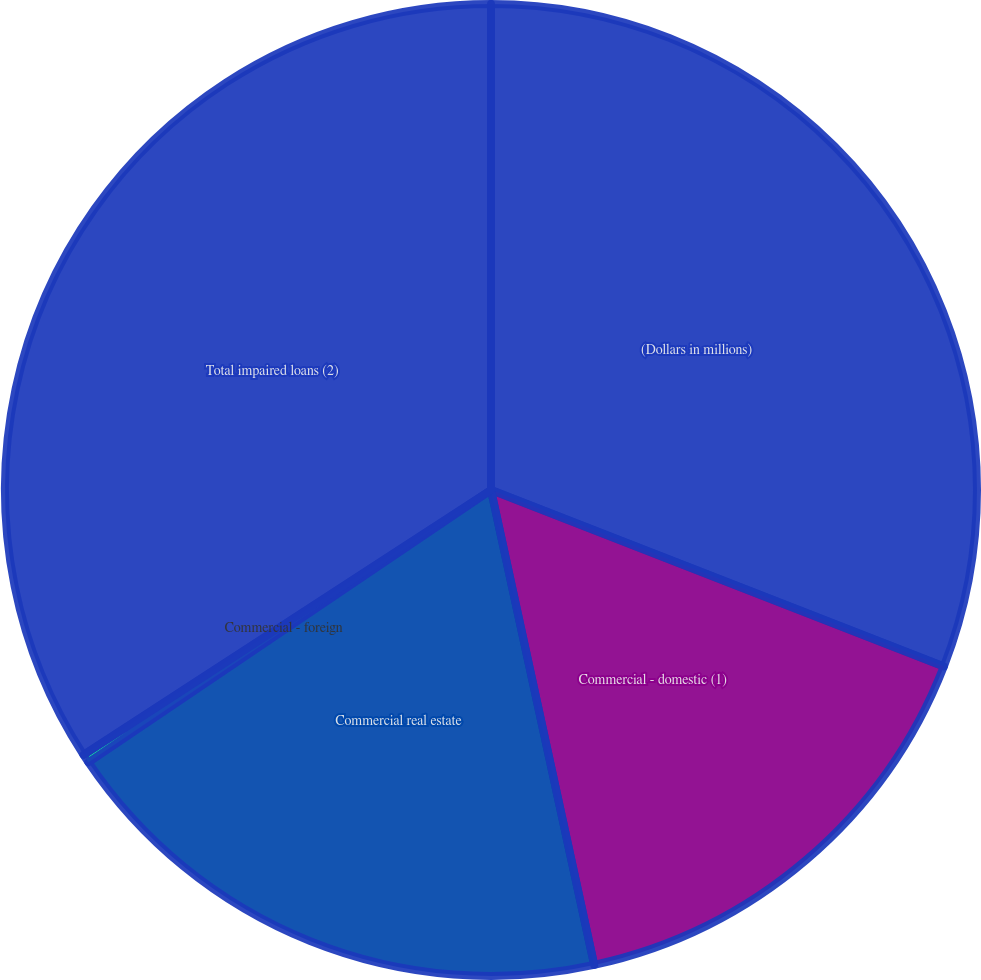Convert chart. <chart><loc_0><loc_0><loc_500><loc_500><pie_chart><fcel>(Dollars in millions)<fcel>Commercial - domestic (1)<fcel>Commercial real estate<fcel>Commercial - foreign<fcel>Total impaired loans (2)<nl><fcel>30.91%<fcel>15.68%<fcel>18.94%<fcel>0.29%<fcel>34.17%<nl></chart> 